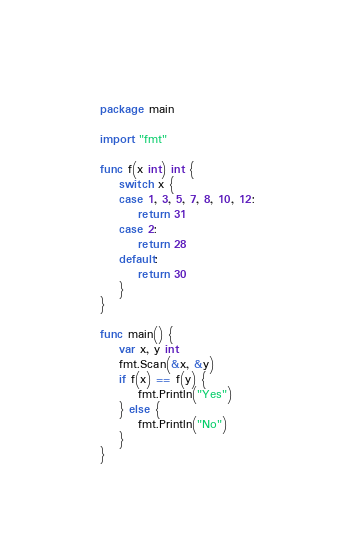Convert code to text. <code><loc_0><loc_0><loc_500><loc_500><_Go_>package main

import "fmt"

func f(x int) int {
	switch x {
	case 1, 3, 5, 7, 8, 10, 12:
		return 31
	case 2:
		return 28
	default:
		return 30
	}
}

func main() {
	var x, y int
	fmt.Scan(&x, &y)
	if f(x) == f(y) {
		fmt.Println("Yes")
	} else {
		fmt.Println("No")
	}
}
</code> 